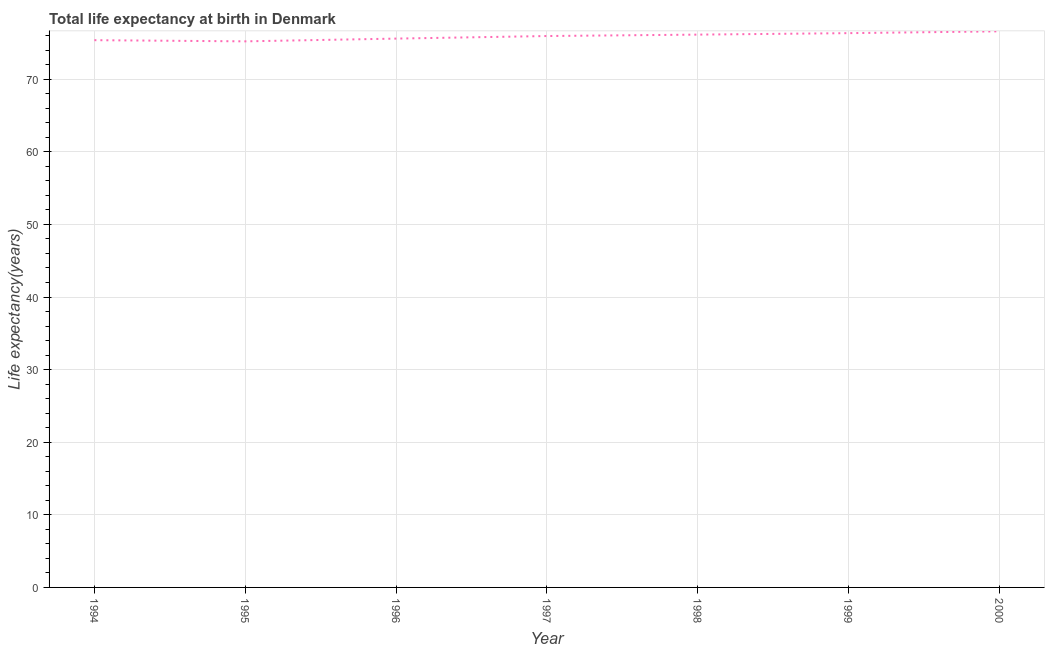What is the life expectancy at birth in 1996?
Keep it short and to the point. 75.59. Across all years, what is the maximum life expectancy at birth?
Your answer should be very brief. 76.59. Across all years, what is the minimum life expectancy at birth?
Give a very brief answer. 75.21. In which year was the life expectancy at birth maximum?
Your answer should be compact. 2000. What is the sum of the life expectancy at birth?
Offer a terse response. 531.2. What is the difference between the life expectancy at birth in 1998 and 1999?
Your response must be concise. -0.2. What is the average life expectancy at birth per year?
Give a very brief answer. 75.89. What is the median life expectancy at birth?
Ensure brevity in your answer.  75.95. What is the ratio of the life expectancy at birth in 1997 to that in 1999?
Make the answer very short. 0.99. Is the life expectancy at birth in 1997 less than that in 1999?
Keep it short and to the point. Yes. Is the difference between the life expectancy at birth in 1995 and 1996 greater than the difference between any two years?
Give a very brief answer. No. What is the difference between the highest and the second highest life expectancy at birth?
Keep it short and to the point. 0.25. What is the difference between the highest and the lowest life expectancy at birth?
Provide a short and direct response. 1.38. In how many years, is the life expectancy at birth greater than the average life expectancy at birth taken over all years?
Provide a succinct answer. 4. Does the life expectancy at birth monotonically increase over the years?
Keep it short and to the point. No. How many lines are there?
Keep it short and to the point. 1. What is the title of the graph?
Your answer should be very brief. Total life expectancy at birth in Denmark. What is the label or title of the X-axis?
Make the answer very short. Year. What is the label or title of the Y-axis?
Make the answer very short. Life expectancy(years). What is the Life expectancy(years) in 1994?
Provide a short and direct response. 75.38. What is the Life expectancy(years) in 1995?
Your answer should be compact. 75.21. What is the Life expectancy(years) in 1996?
Provide a succinct answer. 75.59. What is the Life expectancy(years) of 1997?
Offer a terse response. 75.95. What is the Life expectancy(years) in 1998?
Your answer should be compact. 76.14. What is the Life expectancy(years) of 1999?
Offer a terse response. 76.34. What is the Life expectancy(years) in 2000?
Keep it short and to the point. 76.59. What is the difference between the Life expectancy(years) in 1994 and 1995?
Give a very brief answer. 0.16. What is the difference between the Life expectancy(years) in 1994 and 1996?
Provide a succinct answer. -0.22. What is the difference between the Life expectancy(years) in 1994 and 1997?
Your answer should be very brief. -0.57. What is the difference between the Life expectancy(years) in 1994 and 1998?
Make the answer very short. -0.76. What is the difference between the Life expectancy(years) in 1994 and 1999?
Your answer should be very brief. -0.97. What is the difference between the Life expectancy(years) in 1994 and 2000?
Your response must be concise. -1.22. What is the difference between the Life expectancy(years) in 1995 and 1996?
Offer a very short reply. -0.38. What is the difference between the Life expectancy(years) in 1995 and 1997?
Ensure brevity in your answer.  -0.73. What is the difference between the Life expectancy(years) in 1995 and 1998?
Give a very brief answer. -0.93. What is the difference between the Life expectancy(years) in 1995 and 1999?
Your answer should be very brief. -1.13. What is the difference between the Life expectancy(years) in 1995 and 2000?
Your response must be concise. -1.38. What is the difference between the Life expectancy(years) in 1996 and 1997?
Provide a short and direct response. -0.35. What is the difference between the Life expectancy(years) in 1996 and 1998?
Keep it short and to the point. -0.55. What is the difference between the Life expectancy(years) in 1996 and 1999?
Provide a succinct answer. -0.75. What is the difference between the Life expectancy(years) in 1996 and 2000?
Provide a succinct answer. -1. What is the difference between the Life expectancy(years) in 1997 and 1998?
Offer a very short reply. -0.19. What is the difference between the Life expectancy(years) in 1997 and 1999?
Make the answer very short. -0.4. What is the difference between the Life expectancy(years) in 1997 and 2000?
Provide a short and direct response. -0.65. What is the difference between the Life expectancy(years) in 1998 and 1999?
Make the answer very short. -0.2. What is the difference between the Life expectancy(years) in 1998 and 2000?
Your answer should be very brief. -0.45. What is the difference between the Life expectancy(years) in 1999 and 2000?
Offer a terse response. -0.25. What is the ratio of the Life expectancy(years) in 1994 to that in 1995?
Provide a short and direct response. 1. What is the ratio of the Life expectancy(years) in 1994 to that in 1997?
Ensure brevity in your answer.  0.99. What is the ratio of the Life expectancy(years) in 1994 to that in 1999?
Provide a succinct answer. 0.99. What is the ratio of the Life expectancy(years) in 1995 to that in 1998?
Provide a short and direct response. 0.99. What is the ratio of the Life expectancy(years) in 1995 to that in 1999?
Your answer should be compact. 0.98. What is the ratio of the Life expectancy(years) in 1995 to that in 2000?
Your answer should be compact. 0.98. What is the ratio of the Life expectancy(years) in 1996 to that in 1998?
Your answer should be very brief. 0.99. What is the ratio of the Life expectancy(years) in 1996 to that in 1999?
Offer a very short reply. 0.99. What is the ratio of the Life expectancy(years) in 1996 to that in 2000?
Keep it short and to the point. 0.99. What is the ratio of the Life expectancy(years) in 1997 to that in 1998?
Give a very brief answer. 1. What is the ratio of the Life expectancy(years) in 1999 to that in 2000?
Offer a terse response. 1. 